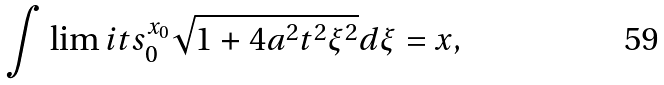<formula> <loc_0><loc_0><loc_500><loc_500>\int \lim i t s _ { 0 } ^ { x _ { 0 } } \sqrt { 1 + 4 a ^ { 2 } t ^ { 2 } { \xi } ^ { 2 } } d { \xi } = x ,</formula> 